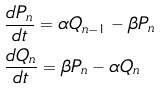<formula> <loc_0><loc_0><loc_500><loc_500>& \frac { d P _ { n } } { d t } = \alpha Q _ { n - 1 } - \beta P _ { n } \\ & \frac { d Q _ { n } } { d t } = \beta P _ { n } - \alpha Q _ { n }</formula> 